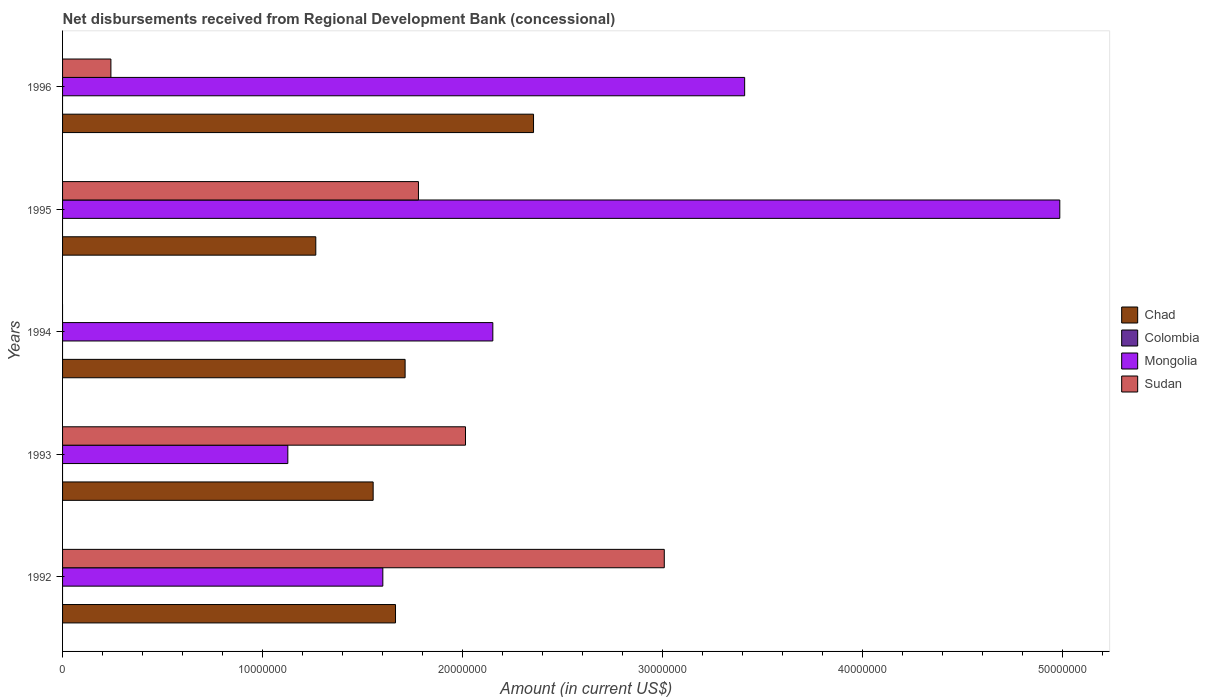How many groups of bars are there?
Your response must be concise. 5. Are the number of bars per tick equal to the number of legend labels?
Offer a very short reply. No. Are the number of bars on each tick of the Y-axis equal?
Provide a short and direct response. No. How many bars are there on the 3rd tick from the bottom?
Your answer should be very brief. 2. What is the amount of disbursements received from Regional Development Bank in Mongolia in 1992?
Offer a very short reply. 1.60e+07. Across all years, what is the maximum amount of disbursements received from Regional Development Bank in Mongolia?
Your response must be concise. 4.99e+07. Across all years, what is the minimum amount of disbursements received from Regional Development Bank in Chad?
Offer a very short reply. 1.27e+07. What is the total amount of disbursements received from Regional Development Bank in Sudan in the graph?
Offer a terse response. 7.04e+07. What is the difference between the amount of disbursements received from Regional Development Bank in Mongolia in 1995 and that in 1996?
Keep it short and to the point. 1.58e+07. What is the difference between the amount of disbursements received from Regional Development Bank in Colombia in 1992 and the amount of disbursements received from Regional Development Bank in Chad in 1994?
Provide a short and direct response. -1.71e+07. What is the average amount of disbursements received from Regional Development Bank in Sudan per year?
Provide a succinct answer. 1.41e+07. In the year 1992, what is the difference between the amount of disbursements received from Regional Development Bank in Mongolia and amount of disbursements received from Regional Development Bank in Chad?
Your answer should be compact. -6.34e+05. In how many years, is the amount of disbursements received from Regional Development Bank in Colombia greater than 34000000 US$?
Provide a short and direct response. 0. What is the ratio of the amount of disbursements received from Regional Development Bank in Chad in 1993 to that in 1996?
Make the answer very short. 0.66. Is the amount of disbursements received from Regional Development Bank in Sudan in 1995 less than that in 1996?
Make the answer very short. No. What is the difference between the highest and the second highest amount of disbursements received from Regional Development Bank in Mongolia?
Your answer should be compact. 1.58e+07. What is the difference between the highest and the lowest amount of disbursements received from Regional Development Bank in Sudan?
Your answer should be very brief. 3.01e+07. In how many years, is the amount of disbursements received from Regional Development Bank in Colombia greater than the average amount of disbursements received from Regional Development Bank in Colombia taken over all years?
Make the answer very short. 0. Is it the case that in every year, the sum of the amount of disbursements received from Regional Development Bank in Chad and amount of disbursements received from Regional Development Bank in Colombia is greater than the sum of amount of disbursements received from Regional Development Bank in Mongolia and amount of disbursements received from Regional Development Bank in Sudan?
Make the answer very short. No. Is it the case that in every year, the sum of the amount of disbursements received from Regional Development Bank in Sudan and amount of disbursements received from Regional Development Bank in Chad is greater than the amount of disbursements received from Regional Development Bank in Colombia?
Give a very brief answer. Yes. How many bars are there?
Your answer should be compact. 14. Are all the bars in the graph horizontal?
Your response must be concise. Yes. What is the difference between two consecutive major ticks on the X-axis?
Ensure brevity in your answer.  1.00e+07. Does the graph contain grids?
Give a very brief answer. No. Where does the legend appear in the graph?
Offer a terse response. Center right. How are the legend labels stacked?
Your answer should be compact. Vertical. What is the title of the graph?
Ensure brevity in your answer.  Net disbursements received from Regional Development Bank (concessional). What is the label or title of the Y-axis?
Your answer should be compact. Years. What is the Amount (in current US$) of Chad in 1992?
Keep it short and to the point. 1.66e+07. What is the Amount (in current US$) of Mongolia in 1992?
Provide a short and direct response. 1.60e+07. What is the Amount (in current US$) of Sudan in 1992?
Your answer should be compact. 3.01e+07. What is the Amount (in current US$) of Chad in 1993?
Ensure brevity in your answer.  1.55e+07. What is the Amount (in current US$) in Colombia in 1993?
Your response must be concise. 0. What is the Amount (in current US$) in Mongolia in 1993?
Make the answer very short. 1.13e+07. What is the Amount (in current US$) of Sudan in 1993?
Offer a terse response. 2.01e+07. What is the Amount (in current US$) in Chad in 1994?
Your response must be concise. 1.71e+07. What is the Amount (in current US$) of Mongolia in 1994?
Provide a short and direct response. 2.15e+07. What is the Amount (in current US$) of Chad in 1995?
Make the answer very short. 1.27e+07. What is the Amount (in current US$) of Colombia in 1995?
Offer a very short reply. 0. What is the Amount (in current US$) of Mongolia in 1995?
Your answer should be very brief. 4.99e+07. What is the Amount (in current US$) of Sudan in 1995?
Your answer should be very brief. 1.78e+07. What is the Amount (in current US$) in Chad in 1996?
Your response must be concise. 2.35e+07. What is the Amount (in current US$) in Mongolia in 1996?
Give a very brief answer. 3.41e+07. What is the Amount (in current US$) in Sudan in 1996?
Keep it short and to the point. 2.42e+06. Across all years, what is the maximum Amount (in current US$) of Chad?
Ensure brevity in your answer.  2.35e+07. Across all years, what is the maximum Amount (in current US$) in Mongolia?
Make the answer very short. 4.99e+07. Across all years, what is the maximum Amount (in current US$) of Sudan?
Offer a very short reply. 3.01e+07. Across all years, what is the minimum Amount (in current US$) in Chad?
Your answer should be very brief. 1.27e+07. Across all years, what is the minimum Amount (in current US$) of Mongolia?
Your answer should be very brief. 1.13e+07. What is the total Amount (in current US$) in Chad in the graph?
Offer a very short reply. 8.55e+07. What is the total Amount (in current US$) in Mongolia in the graph?
Offer a terse response. 1.33e+08. What is the total Amount (in current US$) in Sudan in the graph?
Keep it short and to the point. 7.04e+07. What is the difference between the Amount (in current US$) of Chad in 1992 and that in 1993?
Provide a succinct answer. 1.12e+06. What is the difference between the Amount (in current US$) in Mongolia in 1992 and that in 1993?
Make the answer very short. 4.75e+06. What is the difference between the Amount (in current US$) of Sudan in 1992 and that in 1993?
Keep it short and to the point. 9.94e+06. What is the difference between the Amount (in current US$) of Chad in 1992 and that in 1994?
Give a very brief answer. -4.80e+05. What is the difference between the Amount (in current US$) in Mongolia in 1992 and that in 1994?
Offer a terse response. -5.50e+06. What is the difference between the Amount (in current US$) in Chad in 1992 and that in 1995?
Offer a terse response. 3.99e+06. What is the difference between the Amount (in current US$) in Mongolia in 1992 and that in 1995?
Keep it short and to the point. -3.38e+07. What is the difference between the Amount (in current US$) in Sudan in 1992 and that in 1995?
Keep it short and to the point. 1.23e+07. What is the difference between the Amount (in current US$) of Chad in 1992 and that in 1996?
Provide a succinct answer. -6.90e+06. What is the difference between the Amount (in current US$) in Mongolia in 1992 and that in 1996?
Provide a succinct answer. -1.81e+07. What is the difference between the Amount (in current US$) in Sudan in 1992 and that in 1996?
Your answer should be very brief. 2.77e+07. What is the difference between the Amount (in current US$) of Chad in 1993 and that in 1994?
Offer a terse response. -1.60e+06. What is the difference between the Amount (in current US$) in Mongolia in 1993 and that in 1994?
Your response must be concise. -1.02e+07. What is the difference between the Amount (in current US$) of Chad in 1993 and that in 1995?
Your answer should be compact. 2.87e+06. What is the difference between the Amount (in current US$) in Mongolia in 1993 and that in 1995?
Make the answer very short. -3.86e+07. What is the difference between the Amount (in current US$) of Sudan in 1993 and that in 1995?
Make the answer very short. 2.35e+06. What is the difference between the Amount (in current US$) of Chad in 1993 and that in 1996?
Give a very brief answer. -8.02e+06. What is the difference between the Amount (in current US$) in Mongolia in 1993 and that in 1996?
Provide a short and direct response. -2.28e+07. What is the difference between the Amount (in current US$) in Sudan in 1993 and that in 1996?
Ensure brevity in your answer.  1.77e+07. What is the difference between the Amount (in current US$) in Chad in 1994 and that in 1995?
Keep it short and to the point. 4.47e+06. What is the difference between the Amount (in current US$) of Mongolia in 1994 and that in 1995?
Your answer should be very brief. -2.83e+07. What is the difference between the Amount (in current US$) in Chad in 1994 and that in 1996?
Provide a succinct answer. -6.42e+06. What is the difference between the Amount (in current US$) in Mongolia in 1994 and that in 1996?
Your answer should be compact. -1.26e+07. What is the difference between the Amount (in current US$) of Chad in 1995 and that in 1996?
Your answer should be very brief. -1.09e+07. What is the difference between the Amount (in current US$) of Mongolia in 1995 and that in 1996?
Provide a short and direct response. 1.58e+07. What is the difference between the Amount (in current US$) in Sudan in 1995 and that in 1996?
Provide a short and direct response. 1.54e+07. What is the difference between the Amount (in current US$) in Chad in 1992 and the Amount (in current US$) in Mongolia in 1993?
Give a very brief answer. 5.38e+06. What is the difference between the Amount (in current US$) of Chad in 1992 and the Amount (in current US$) of Sudan in 1993?
Offer a very short reply. -3.50e+06. What is the difference between the Amount (in current US$) in Mongolia in 1992 and the Amount (in current US$) in Sudan in 1993?
Keep it short and to the point. -4.13e+06. What is the difference between the Amount (in current US$) in Chad in 1992 and the Amount (in current US$) in Mongolia in 1994?
Your answer should be compact. -4.87e+06. What is the difference between the Amount (in current US$) in Chad in 1992 and the Amount (in current US$) in Mongolia in 1995?
Give a very brief answer. -3.32e+07. What is the difference between the Amount (in current US$) in Chad in 1992 and the Amount (in current US$) in Sudan in 1995?
Your answer should be very brief. -1.15e+06. What is the difference between the Amount (in current US$) in Mongolia in 1992 and the Amount (in current US$) in Sudan in 1995?
Your answer should be compact. -1.78e+06. What is the difference between the Amount (in current US$) in Chad in 1992 and the Amount (in current US$) in Mongolia in 1996?
Keep it short and to the point. -1.75e+07. What is the difference between the Amount (in current US$) in Chad in 1992 and the Amount (in current US$) in Sudan in 1996?
Keep it short and to the point. 1.42e+07. What is the difference between the Amount (in current US$) in Mongolia in 1992 and the Amount (in current US$) in Sudan in 1996?
Keep it short and to the point. 1.36e+07. What is the difference between the Amount (in current US$) of Chad in 1993 and the Amount (in current US$) of Mongolia in 1994?
Your answer should be compact. -5.98e+06. What is the difference between the Amount (in current US$) of Chad in 1993 and the Amount (in current US$) of Mongolia in 1995?
Make the answer very short. -3.43e+07. What is the difference between the Amount (in current US$) in Chad in 1993 and the Amount (in current US$) in Sudan in 1995?
Ensure brevity in your answer.  -2.26e+06. What is the difference between the Amount (in current US$) of Mongolia in 1993 and the Amount (in current US$) of Sudan in 1995?
Your answer should be compact. -6.53e+06. What is the difference between the Amount (in current US$) of Chad in 1993 and the Amount (in current US$) of Mongolia in 1996?
Offer a terse response. -1.86e+07. What is the difference between the Amount (in current US$) in Chad in 1993 and the Amount (in current US$) in Sudan in 1996?
Ensure brevity in your answer.  1.31e+07. What is the difference between the Amount (in current US$) of Mongolia in 1993 and the Amount (in current US$) of Sudan in 1996?
Provide a short and direct response. 8.85e+06. What is the difference between the Amount (in current US$) in Chad in 1994 and the Amount (in current US$) in Mongolia in 1995?
Your response must be concise. -3.27e+07. What is the difference between the Amount (in current US$) in Chad in 1994 and the Amount (in current US$) in Sudan in 1995?
Offer a very short reply. -6.67e+05. What is the difference between the Amount (in current US$) of Mongolia in 1994 and the Amount (in current US$) of Sudan in 1995?
Ensure brevity in your answer.  3.72e+06. What is the difference between the Amount (in current US$) in Chad in 1994 and the Amount (in current US$) in Mongolia in 1996?
Offer a terse response. -1.70e+07. What is the difference between the Amount (in current US$) of Chad in 1994 and the Amount (in current US$) of Sudan in 1996?
Give a very brief answer. 1.47e+07. What is the difference between the Amount (in current US$) of Mongolia in 1994 and the Amount (in current US$) of Sudan in 1996?
Provide a short and direct response. 1.91e+07. What is the difference between the Amount (in current US$) of Chad in 1995 and the Amount (in current US$) of Mongolia in 1996?
Offer a very short reply. -2.14e+07. What is the difference between the Amount (in current US$) in Chad in 1995 and the Amount (in current US$) in Sudan in 1996?
Keep it short and to the point. 1.02e+07. What is the difference between the Amount (in current US$) in Mongolia in 1995 and the Amount (in current US$) in Sudan in 1996?
Ensure brevity in your answer.  4.74e+07. What is the average Amount (in current US$) of Chad per year?
Provide a short and direct response. 1.71e+07. What is the average Amount (in current US$) of Mongolia per year?
Offer a terse response. 2.66e+07. What is the average Amount (in current US$) in Sudan per year?
Your answer should be very brief. 1.41e+07. In the year 1992, what is the difference between the Amount (in current US$) of Chad and Amount (in current US$) of Mongolia?
Your answer should be very brief. 6.34e+05. In the year 1992, what is the difference between the Amount (in current US$) of Chad and Amount (in current US$) of Sudan?
Provide a short and direct response. -1.34e+07. In the year 1992, what is the difference between the Amount (in current US$) of Mongolia and Amount (in current US$) of Sudan?
Offer a very short reply. -1.41e+07. In the year 1993, what is the difference between the Amount (in current US$) of Chad and Amount (in current US$) of Mongolia?
Give a very brief answer. 4.27e+06. In the year 1993, what is the difference between the Amount (in current US$) of Chad and Amount (in current US$) of Sudan?
Ensure brevity in your answer.  -4.62e+06. In the year 1993, what is the difference between the Amount (in current US$) of Mongolia and Amount (in current US$) of Sudan?
Provide a succinct answer. -8.88e+06. In the year 1994, what is the difference between the Amount (in current US$) in Chad and Amount (in current US$) in Mongolia?
Provide a short and direct response. -4.39e+06. In the year 1995, what is the difference between the Amount (in current US$) of Chad and Amount (in current US$) of Mongolia?
Keep it short and to the point. -3.72e+07. In the year 1995, what is the difference between the Amount (in current US$) of Chad and Amount (in current US$) of Sudan?
Offer a very short reply. -5.13e+06. In the year 1995, what is the difference between the Amount (in current US$) in Mongolia and Amount (in current US$) in Sudan?
Offer a very short reply. 3.21e+07. In the year 1996, what is the difference between the Amount (in current US$) in Chad and Amount (in current US$) in Mongolia?
Make the answer very short. -1.06e+07. In the year 1996, what is the difference between the Amount (in current US$) in Chad and Amount (in current US$) in Sudan?
Provide a short and direct response. 2.11e+07. In the year 1996, what is the difference between the Amount (in current US$) of Mongolia and Amount (in current US$) of Sudan?
Keep it short and to the point. 3.17e+07. What is the ratio of the Amount (in current US$) in Chad in 1992 to that in 1993?
Offer a terse response. 1.07. What is the ratio of the Amount (in current US$) of Mongolia in 1992 to that in 1993?
Provide a succinct answer. 1.42. What is the ratio of the Amount (in current US$) of Sudan in 1992 to that in 1993?
Your answer should be compact. 1.49. What is the ratio of the Amount (in current US$) in Mongolia in 1992 to that in 1994?
Offer a terse response. 0.74. What is the ratio of the Amount (in current US$) of Chad in 1992 to that in 1995?
Your response must be concise. 1.31. What is the ratio of the Amount (in current US$) in Mongolia in 1992 to that in 1995?
Keep it short and to the point. 0.32. What is the ratio of the Amount (in current US$) of Sudan in 1992 to that in 1995?
Your response must be concise. 1.69. What is the ratio of the Amount (in current US$) of Chad in 1992 to that in 1996?
Your answer should be very brief. 0.71. What is the ratio of the Amount (in current US$) of Mongolia in 1992 to that in 1996?
Give a very brief answer. 0.47. What is the ratio of the Amount (in current US$) of Sudan in 1992 to that in 1996?
Make the answer very short. 12.45. What is the ratio of the Amount (in current US$) in Chad in 1993 to that in 1994?
Offer a very short reply. 0.91. What is the ratio of the Amount (in current US$) of Mongolia in 1993 to that in 1994?
Provide a short and direct response. 0.52. What is the ratio of the Amount (in current US$) in Chad in 1993 to that in 1995?
Give a very brief answer. 1.23. What is the ratio of the Amount (in current US$) in Mongolia in 1993 to that in 1995?
Your response must be concise. 0.23. What is the ratio of the Amount (in current US$) of Sudan in 1993 to that in 1995?
Your response must be concise. 1.13. What is the ratio of the Amount (in current US$) in Chad in 1993 to that in 1996?
Provide a succinct answer. 0.66. What is the ratio of the Amount (in current US$) of Mongolia in 1993 to that in 1996?
Keep it short and to the point. 0.33. What is the ratio of the Amount (in current US$) in Sudan in 1993 to that in 1996?
Provide a short and direct response. 8.34. What is the ratio of the Amount (in current US$) of Chad in 1994 to that in 1995?
Make the answer very short. 1.35. What is the ratio of the Amount (in current US$) in Mongolia in 1994 to that in 1995?
Make the answer very short. 0.43. What is the ratio of the Amount (in current US$) of Chad in 1994 to that in 1996?
Ensure brevity in your answer.  0.73. What is the ratio of the Amount (in current US$) of Mongolia in 1994 to that in 1996?
Keep it short and to the point. 0.63. What is the ratio of the Amount (in current US$) in Chad in 1995 to that in 1996?
Give a very brief answer. 0.54. What is the ratio of the Amount (in current US$) in Mongolia in 1995 to that in 1996?
Your response must be concise. 1.46. What is the ratio of the Amount (in current US$) in Sudan in 1995 to that in 1996?
Your answer should be very brief. 7.36. What is the difference between the highest and the second highest Amount (in current US$) in Chad?
Provide a succinct answer. 6.42e+06. What is the difference between the highest and the second highest Amount (in current US$) in Mongolia?
Offer a terse response. 1.58e+07. What is the difference between the highest and the second highest Amount (in current US$) in Sudan?
Keep it short and to the point. 9.94e+06. What is the difference between the highest and the lowest Amount (in current US$) of Chad?
Your response must be concise. 1.09e+07. What is the difference between the highest and the lowest Amount (in current US$) in Mongolia?
Offer a very short reply. 3.86e+07. What is the difference between the highest and the lowest Amount (in current US$) of Sudan?
Give a very brief answer. 3.01e+07. 